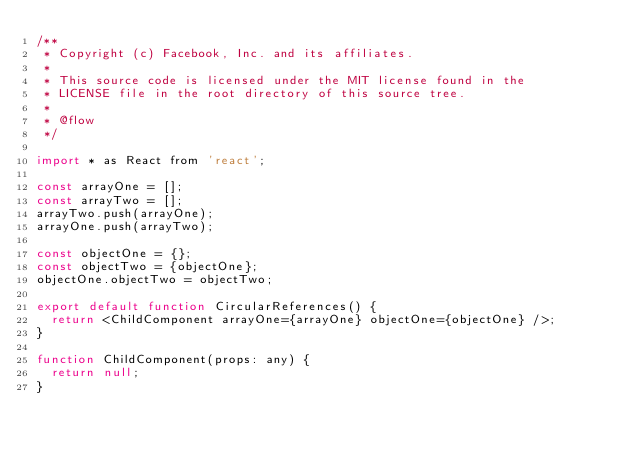Convert code to text. <code><loc_0><loc_0><loc_500><loc_500><_JavaScript_>/**
 * Copyright (c) Facebook, Inc. and its affiliates.
 *
 * This source code is licensed under the MIT license found in the
 * LICENSE file in the root directory of this source tree.
 *
 * @flow
 */

import * as React from 'react';

const arrayOne = [];
const arrayTwo = [];
arrayTwo.push(arrayOne);
arrayOne.push(arrayTwo);

const objectOne = {};
const objectTwo = {objectOne};
objectOne.objectTwo = objectTwo;

export default function CircularReferences() {
  return <ChildComponent arrayOne={arrayOne} objectOne={objectOne} />;
}

function ChildComponent(props: any) {
  return null;
}
</code> 